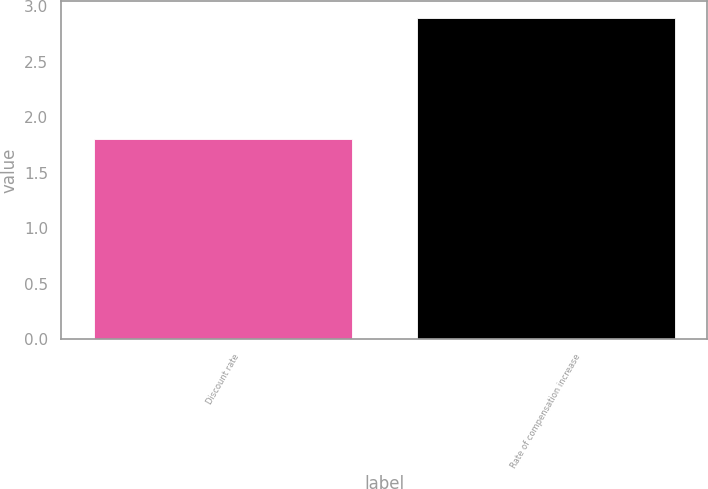Convert chart. <chart><loc_0><loc_0><loc_500><loc_500><bar_chart><fcel>Discount rate<fcel>Rate of compensation increase<nl><fcel>1.8<fcel>2.9<nl></chart> 